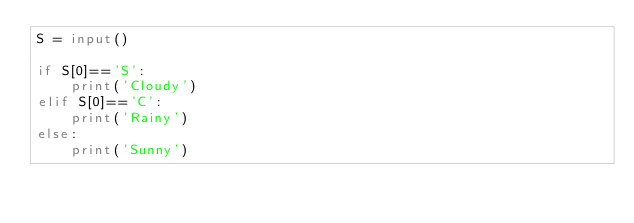<code> <loc_0><loc_0><loc_500><loc_500><_Python_>S = input()
 
if S[0]=='S':
    print('Cloudy')
elif S[0]=='C':
    print('Rainy')
else:
    print('Sunny')</code> 